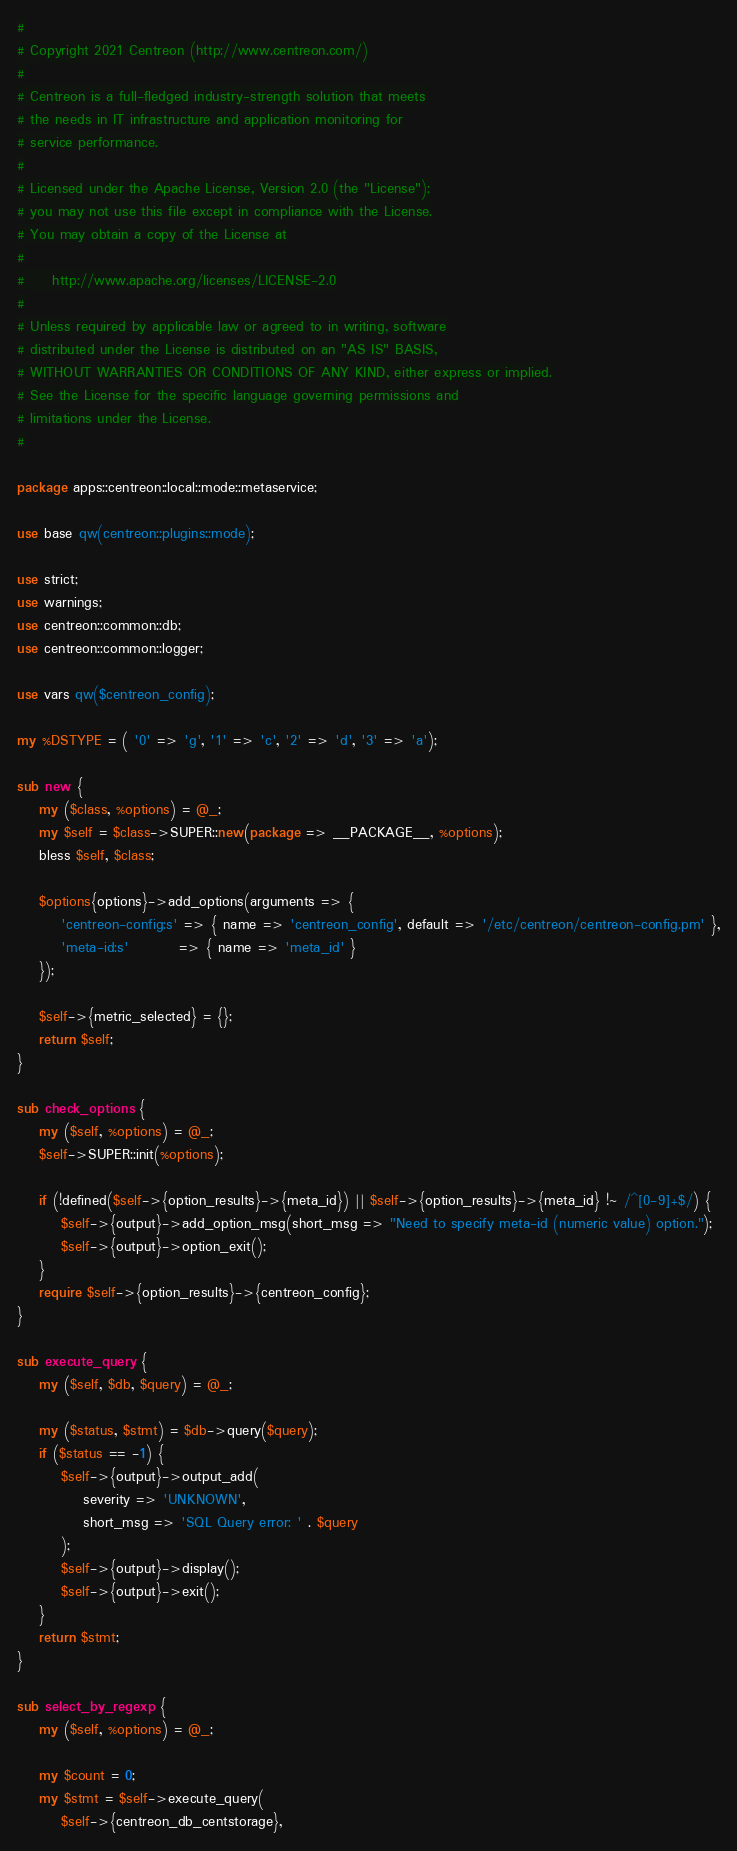Convert code to text. <code><loc_0><loc_0><loc_500><loc_500><_Perl_>#
# Copyright 2021 Centreon (http://www.centreon.com/)
#
# Centreon is a full-fledged industry-strength solution that meets
# the needs in IT infrastructure and application monitoring for
# service performance.
#
# Licensed under the Apache License, Version 2.0 (the "License");
# you may not use this file except in compliance with the License.
# You may obtain a copy of the License at
#
#     http://www.apache.org/licenses/LICENSE-2.0
#
# Unless required by applicable law or agreed to in writing, software
# distributed under the License is distributed on an "AS IS" BASIS,
# WITHOUT WARRANTIES OR CONDITIONS OF ANY KIND, either express or implied.
# See the License for the specific language governing permissions and
# limitations under the License.
#

package apps::centreon::local::mode::metaservice;

use base qw(centreon::plugins::mode);

use strict;
use warnings;
use centreon::common::db;
use centreon::common::logger;

use vars qw($centreon_config);

my %DSTYPE = ( '0' => 'g', '1' => 'c', '2' => 'd', '3' => 'a');

sub new {
    my ($class, %options) = @_;
    my $self = $class->SUPER::new(package => __PACKAGE__, %options);
    bless $self, $class;

    $options{options}->add_options(arguments => { 
        'centreon-config:s' => { name => 'centreon_config', default => '/etc/centreon/centreon-config.pm' },
        'meta-id:s'         => { name => 'meta_id' }
    });

    $self->{metric_selected} = {};
    return $self;
}

sub check_options {
    my ($self, %options) = @_;
    $self->SUPER::init(%options);

    if (!defined($self->{option_results}->{meta_id}) || $self->{option_results}->{meta_id} !~ /^[0-9]+$/) {
        $self->{output}->add_option_msg(short_msg => "Need to specify meta-id (numeric value) option.");
        $self->{output}->option_exit();
    }
    require $self->{option_results}->{centreon_config};
}

sub execute_query {
    my ($self, $db, $query) = @_;

    my ($status, $stmt) = $db->query($query);
    if ($status == -1) {
        $self->{output}->output_add(
            severity => 'UNKNOWN',
            short_msg => 'SQL Query error: ' . $query
        );
        $self->{output}->display();
        $self->{output}->exit();
    }
    return $stmt;
}

sub select_by_regexp {
    my ($self, %options) = @_;

    my $count = 0;
    my $stmt = $self->execute_query(
        $self->{centreon_db_centstorage},</code> 